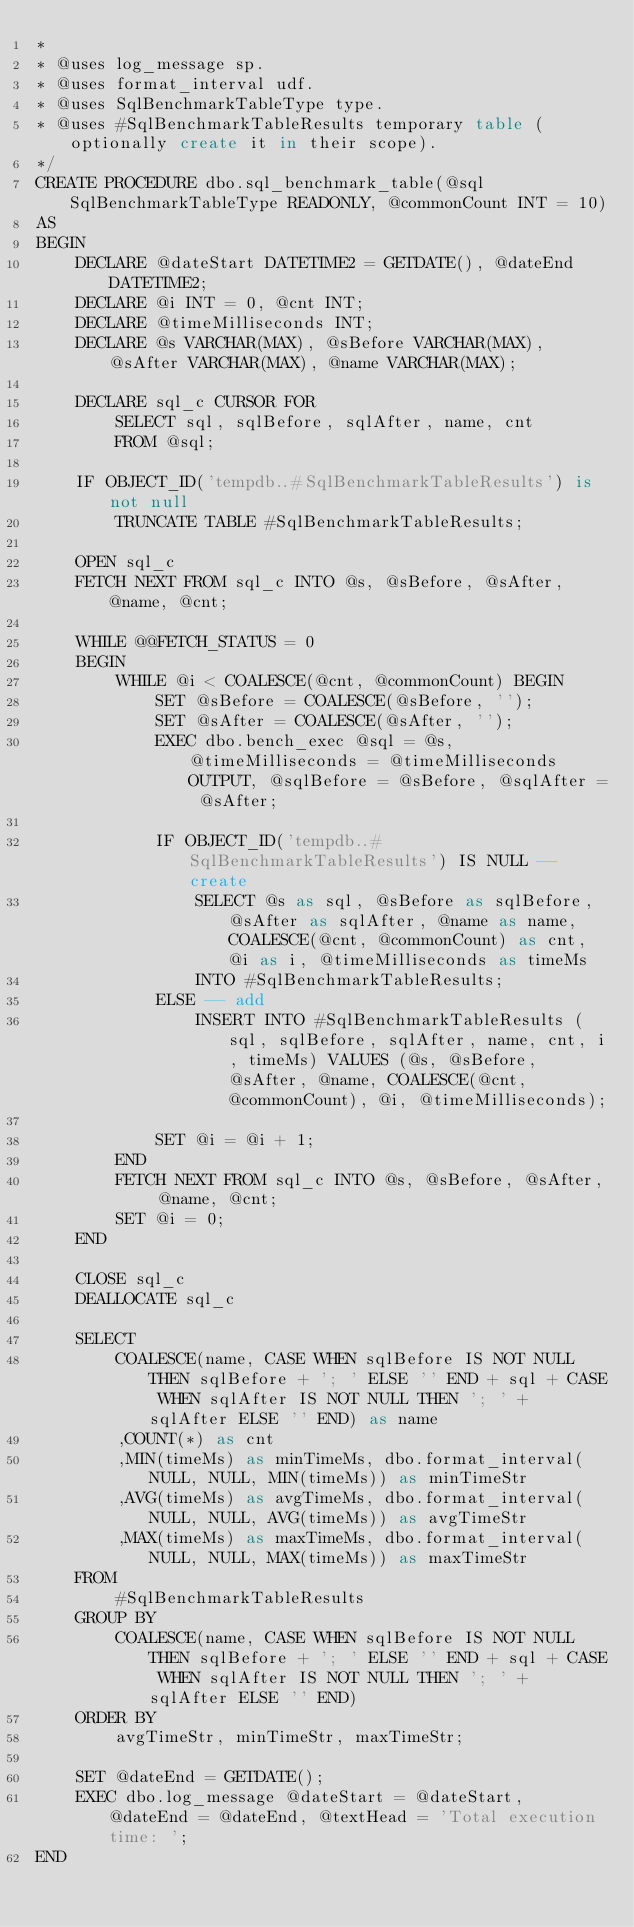Convert code to text. <code><loc_0><loc_0><loc_500><loc_500><_SQL_>*
* @uses log_message sp.
* @uses format_interval udf.
* @uses SqlBenchmarkTableType type.
* @uses #SqlBenchmarkTableResults temporary table (optionally create it in their scope).
*/
CREATE PROCEDURE dbo.sql_benchmark_table(@sql SqlBenchmarkTableType READONLY, @commonCount INT = 10)
AS
BEGIN
	DECLARE @dateStart DATETIME2 = GETDATE(), @dateEnd DATETIME2;
	DECLARE @i INT = 0, @cnt INT;
	DECLARE @timeMilliseconds INT;
	DECLARE @s VARCHAR(MAX), @sBefore VARCHAR(MAX), @sAfter VARCHAR(MAX), @name VARCHAR(MAX);

	DECLARE sql_c CURSOR FOR
		SELECT sql, sqlBefore, sqlAfter, name, cnt
		FROM @sql;

	IF OBJECT_ID('tempdb..#SqlBenchmarkTableResults') is not null
		TRUNCATE TABLE #SqlBenchmarkTableResults;

	OPEN sql_c
	FETCH NEXT FROM sql_c INTO @s, @sBefore, @sAfter, @name, @cnt;

	WHILE @@FETCH_STATUS = 0
	BEGIN
		WHILE @i < COALESCE(@cnt, @commonCount) BEGIN
			SET @sBefore = COALESCE(@sBefore, '');
			SET @sAfter = COALESCE(@sAfter, '');
			EXEC dbo.bench_exec @sql = @s, @timeMilliseconds = @timeMilliseconds OUTPUT, @sqlBefore = @sBefore, @sqlAfter = @sAfter;

			IF OBJECT_ID('tempdb..#SqlBenchmarkTableResults') IS NULL -- create
				SELECT @s as sql, @sBefore as sqlBefore, @sAfter as sqlAfter, @name as name, COALESCE(@cnt, @commonCount) as cnt, @i as i, @timeMilliseconds as timeMs
				INTO #SqlBenchmarkTableResults;
			ELSE -- add
				INSERT INTO #SqlBenchmarkTableResults (sql, sqlBefore, sqlAfter, name, cnt, i, timeMs) VALUES (@s, @sBefore, @sAfter, @name, COALESCE(@cnt, @commonCount), @i, @timeMilliseconds);

			SET @i = @i + 1;
		END
		FETCH NEXT FROM sql_c INTO @s, @sBefore, @sAfter, @name, @cnt;
		SET @i = 0;
	END

	CLOSE sql_c
	DEALLOCATE sql_c

	SELECT
		COALESCE(name, CASE WHEN sqlBefore IS NOT NULL THEN sqlBefore + '; ' ELSE '' END + sql + CASE WHEN sqlAfter IS NOT NULL THEN '; ' + sqlAfter ELSE '' END) as name
		,COUNT(*) as cnt
		,MIN(timeMs) as minTimeMs, dbo.format_interval(NULL, NULL, MIN(timeMs)) as minTimeStr
		,AVG(timeMs) as avgTimeMs, dbo.format_interval(NULL, NULL, AVG(timeMs)) as avgTimeStr
		,MAX(timeMs) as maxTimeMs, dbo.format_interval(NULL, NULL, MAX(timeMs)) as maxTimeStr
	FROM
		#SqlBenchmarkTableResults
	GROUP BY
		COALESCE(name, CASE WHEN sqlBefore IS NOT NULL THEN sqlBefore + '; ' ELSE '' END + sql + CASE WHEN sqlAfter IS NOT NULL THEN '; ' + sqlAfter ELSE '' END)
	ORDER BY
		avgTimeStr, minTimeStr, maxTimeStr;
	
	SET @dateEnd = GETDATE();
	EXEC dbo.log_message @dateStart = @dateStart, @dateEnd = @dateEnd, @textHead = 'Total execution time: ';
END</code> 